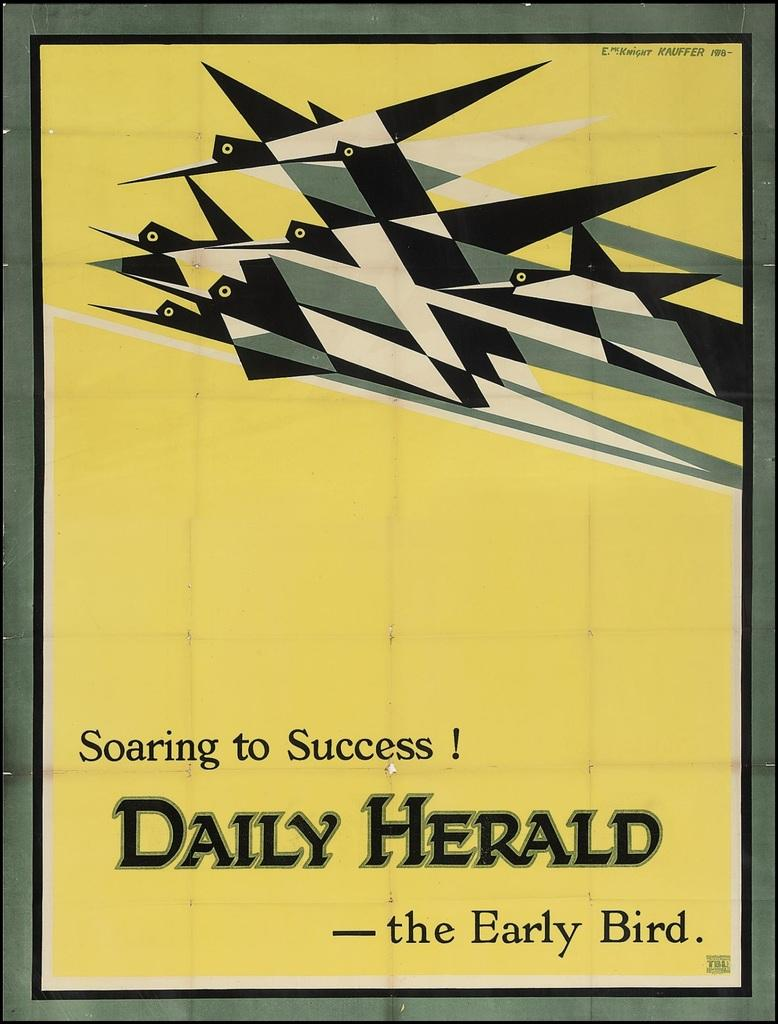<image>
Present a compact description of the photo's key features. A poster for the Daily Herald features the phrase "soaring to success!" 